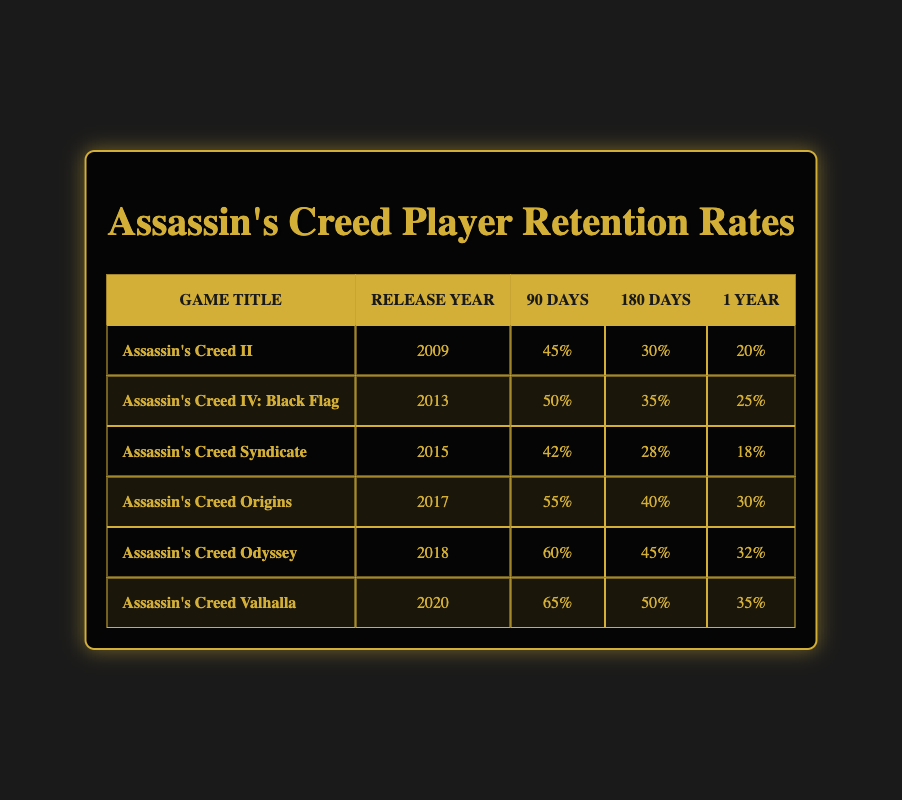What is the highest retention rate at 90 days among the games listed? The retention rates at 90 days for the games are 45%, 50%, 42%, 55%, 60%, and 65%. The highest value among these is 65% for the game Assassin's Creed Valhalla.
Answer: 65% Which game had the lowest retention rate at 180 days? The retention rates at 180 days for the games are 30%, 35%, 28%, 40%, 45%, and 50%. The lowest value among these is 28% for the game Assassin's Creed Syndicate.
Answer: Assassin's Creed Syndicate What is the average retention rate at 1 year for the games listed? The retention rates at 1 year are 20%, 25%, 18%, 30%, 32%, and 35%. Adding these together gives 20 + 25 + 18 + 30 + 32 + 35 = 160. There are 6 games, so the average is 160/6 = 26.67, which we can round to the nearest whole number as 27.
Answer: 27 Is the retention rate at 90 days for Assassin's Creed Odyssey higher than that for Assassin's Creed IV: Black Flag? The retention rate at 90 days for Assassin's Creed Odyssey is 60%, and for Assassin's Creed IV: Black Flag, it is 50%. Since 60% is greater than 50%, the statement is true.
Answer: Yes Which game showed the most improvement in retention rates from 90 days to 1 year? Calculating the difference between 90 days and 1 year retention rates for each game: Assassin's Creed II: 45% - 20% = 25%, Assassin's Creed IV: Black Flag: 50% - 25% = 25%, Assassin's Creed Syndicate: 42% - 18% = 24%, Assassin's Creed Origins: 55% - 30% = 25%, Assassin's Creed Odyssey: 60% - 32% = 28%, and Assassin's Creed Valhalla: 65% - 35% = 30%. The greatest difference is 30% for Assassin's Creed Valhalla.
Answer: Assassin's Creed Valhalla What is the total retention rate at 180 days for all the games combined? The retention rates at 180 days are 30%, 35%, 28%, 40%, 45%, and 50%. Adding these gives 30 + 35 + 28 + 40 + 45 + 50 = 228.
Answer: 228 